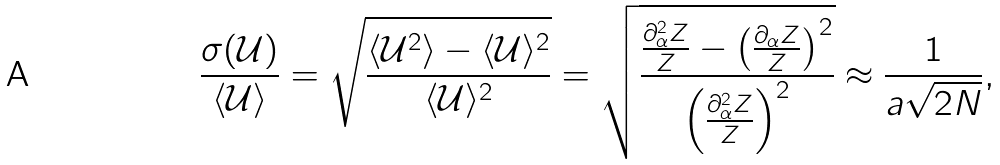<formula> <loc_0><loc_0><loc_500><loc_500>\frac { \sigma ( \mathcal { U } ) } { \langle \mathcal { U } \rangle } = \sqrt { \frac { \langle \mathcal { U } ^ { 2 } \rangle - \langle \mathcal { U } \rangle ^ { 2 } } { \langle \mathcal { U } \rangle ^ { 2 } } } = \sqrt { \frac { \frac { \partial _ { \alpha } ^ { 2 } Z } { Z } - \left ( \frac { \partial _ { \alpha } Z } { Z } \right ) ^ { 2 } } { \left ( \frac { \partial _ { \alpha } ^ { 2 } Z } { Z } \right ) ^ { 2 } } } \approx \frac { 1 } { a \sqrt { 2 N } } ,</formula> 